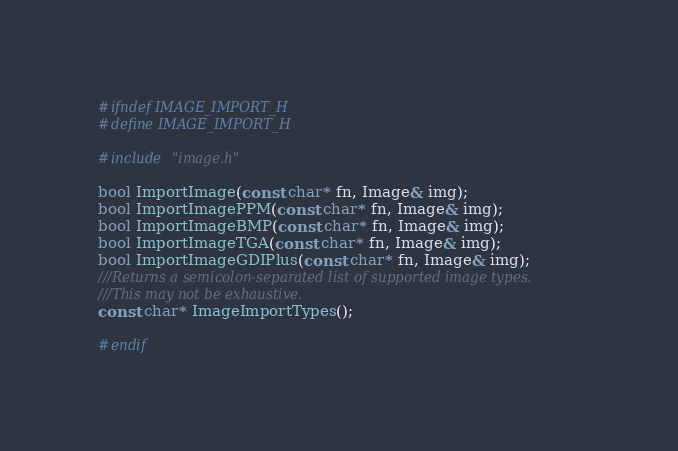Convert code to text. <code><loc_0><loc_0><loc_500><loc_500><_C_>#ifndef IMAGE_IMPORT_H
#define IMAGE_IMPORT_H

#include "image.h"

bool ImportImage(const char* fn, Image& img);
bool ImportImagePPM(const char* fn, Image& img);
bool ImportImageBMP(const char* fn, Image& img);
bool ImportImageTGA(const char* fn, Image& img);
bool ImportImageGDIPlus(const char* fn, Image& img);
///Returns a semicolon-separated list of supported image types.
///This may not be exhaustive.
const char* ImageImportTypes();

#endif
</code> 